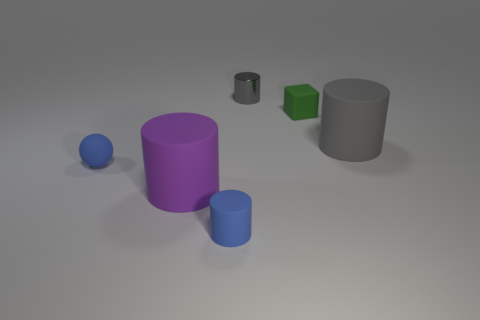Add 4 purple spheres. How many objects exist? 10 Subtract all red blocks. Subtract all brown balls. How many blocks are left? 1 Subtract all spheres. How many objects are left? 5 Add 5 small cubes. How many small cubes exist? 6 Subtract 0 cyan blocks. How many objects are left? 6 Subtract all red metal balls. Subtract all rubber balls. How many objects are left? 5 Add 3 small gray things. How many small gray things are left? 4 